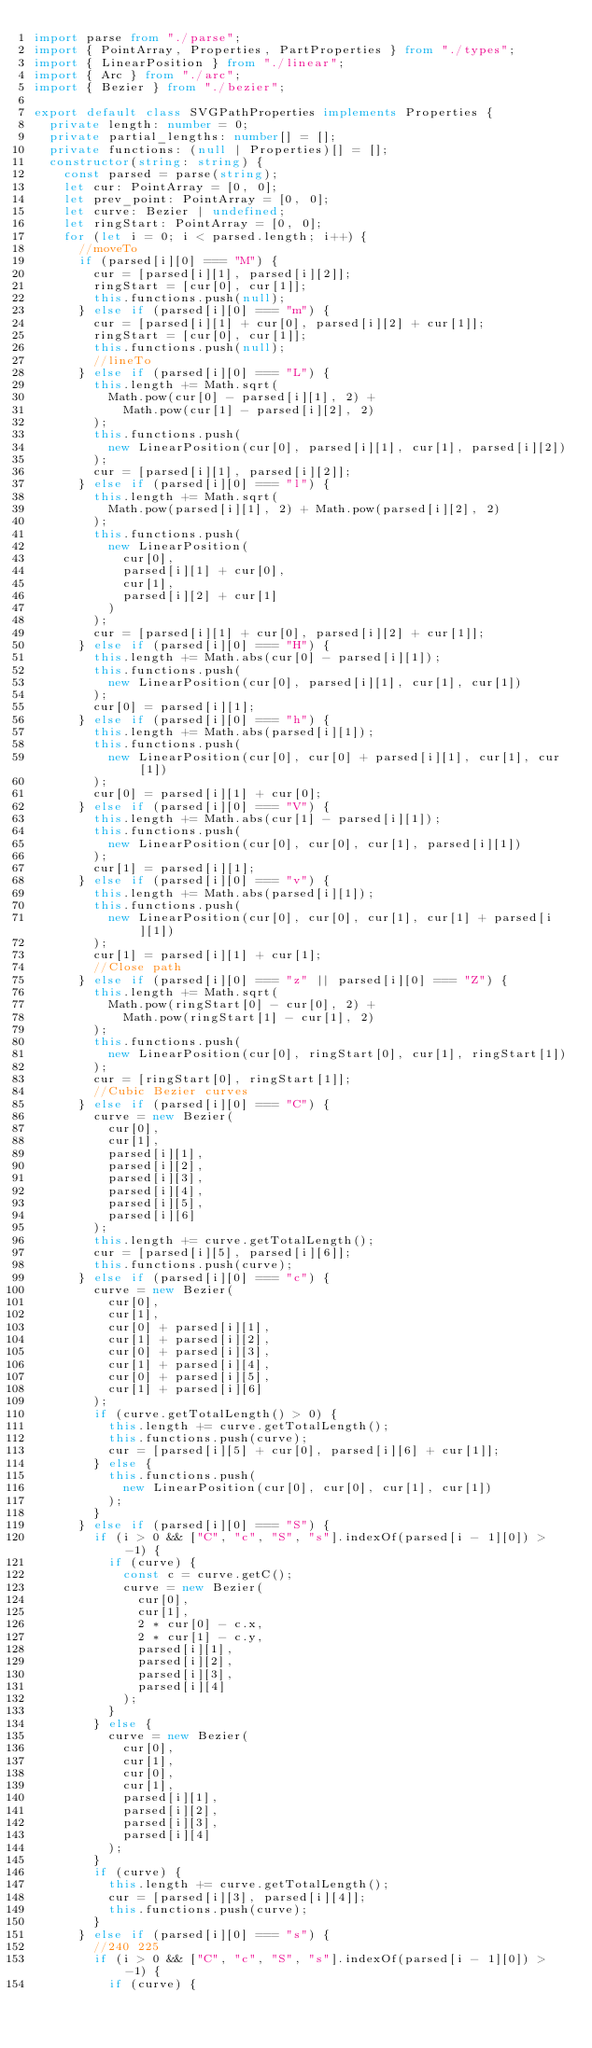<code> <loc_0><loc_0><loc_500><loc_500><_TypeScript_>import parse from "./parse";
import { PointArray, Properties, PartProperties } from "./types";
import { LinearPosition } from "./linear";
import { Arc } from "./arc";
import { Bezier } from "./bezier";

export default class SVGPathProperties implements Properties {
  private length: number = 0;
  private partial_lengths: number[] = [];
  private functions: (null | Properties)[] = [];
  constructor(string: string) {
    const parsed = parse(string);
    let cur: PointArray = [0, 0];
    let prev_point: PointArray = [0, 0];
    let curve: Bezier | undefined;
    let ringStart: PointArray = [0, 0];
    for (let i = 0; i < parsed.length; i++) {
      //moveTo
      if (parsed[i][0] === "M") {
        cur = [parsed[i][1], parsed[i][2]];
        ringStart = [cur[0], cur[1]];
        this.functions.push(null);
      } else if (parsed[i][0] === "m") {
        cur = [parsed[i][1] + cur[0], parsed[i][2] + cur[1]];
        ringStart = [cur[0], cur[1]];
        this.functions.push(null);
        //lineTo
      } else if (parsed[i][0] === "L") {
        this.length += Math.sqrt(
          Math.pow(cur[0] - parsed[i][1], 2) +
            Math.pow(cur[1] - parsed[i][2], 2)
        );
        this.functions.push(
          new LinearPosition(cur[0], parsed[i][1], cur[1], parsed[i][2])
        );
        cur = [parsed[i][1], parsed[i][2]];
      } else if (parsed[i][0] === "l") {
        this.length += Math.sqrt(
          Math.pow(parsed[i][1], 2) + Math.pow(parsed[i][2], 2)
        );
        this.functions.push(
          new LinearPosition(
            cur[0],
            parsed[i][1] + cur[0],
            cur[1],
            parsed[i][2] + cur[1]
          )
        );
        cur = [parsed[i][1] + cur[0], parsed[i][2] + cur[1]];
      } else if (parsed[i][0] === "H") {
        this.length += Math.abs(cur[0] - parsed[i][1]);
        this.functions.push(
          new LinearPosition(cur[0], parsed[i][1], cur[1], cur[1])
        );
        cur[0] = parsed[i][1];
      } else if (parsed[i][0] === "h") {
        this.length += Math.abs(parsed[i][1]);
        this.functions.push(
          new LinearPosition(cur[0], cur[0] + parsed[i][1], cur[1], cur[1])
        );
        cur[0] = parsed[i][1] + cur[0];
      } else if (parsed[i][0] === "V") {
        this.length += Math.abs(cur[1] - parsed[i][1]);
        this.functions.push(
          new LinearPosition(cur[0], cur[0], cur[1], parsed[i][1])
        );
        cur[1] = parsed[i][1];
      } else if (parsed[i][0] === "v") {
        this.length += Math.abs(parsed[i][1]);
        this.functions.push(
          new LinearPosition(cur[0], cur[0], cur[1], cur[1] + parsed[i][1])
        );
        cur[1] = parsed[i][1] + cur[1];
        //Close path
      } else if (parsed[i][0] === "z" || parsed[i][0] === "Z") {
        this.length += Math.sqrt(
          Math.pow(ringStart[0] - cur[0], 2) +
            Math.pow(ringStart[1] - cur[1], 2)
        );
        this.functions.push(
          new LinearPosition(cur[0], ringStart[0], cur[1], ringStart[1])
        );
        cur = [ringStart[0], ringStart[1]];
        //Cubic Bezier curves
      } else if (parsed[i][0] === "C") {
        curve = new Bezier(
          cur[0],
          cur[1],
          parsed[i][1],
          parsed[i][2],
          parsed[i][3],
          parsed[i][4],
          parsed[i][5],
          parsed[i][6]
        );
        this.length += curve.getTotalLength();
        cur = [parsed[i][5], parsed[i][6]];
        this.functions.push(curve);
      } else if (parsed[i][0] === "c") {
        curve = new Bezier(
          cur[0],
          cur[1],
          cur[0] + parsed[i][1],
          cur[1] + parsed[i][2],
          cur[0] + parsed[i][3],
          cur[1] + parsed[i][4],
          cur[0] + parsed[i][5],
          cur[1] + parsed[i][6]
        );
        if (curve.getTotalLength() > 0) {
          this.length += curve.getTotalLength();
          this.functions.push(curve);
          cur = [parsed[i][5] + cur[0], parsed[i][6] + cur[1]];
        } else {
          this.functions.push(
            new LinearPosition(cur[0], cur[0], cur[1], cur[1])
          );
        }
      } else if (parsed[i][0] === "S") {
        if (i > 0 && ["C", "c", "S", "s"].indexOf(parsed[i - 1][0]) > -1) {
          if (curve) {
            const c = curve.getC();
            curve = new Bezier(
              cur[0],
              cur[1],
              2 * cur[0] - c.x,
              2 * cur[1] - c.y,
              parsed[i][1],
              parsed[i][2],
              parsed[i][3],
              parsed[i][4]
            );
          }
        } else {
          curve = new Bezier(
            cur[0],
            cur[1],
            cur[0],
            cur[1],
            parsed[i][1],
            parsed[i][2],
            parsed[i][3],
            parsed[i][4]
          );
        }
        if (curve) {
          this.length += curve.getTotalLength();
          cur = [parsed[i][3], parsed[i][4]];
          this.functions.push(curve);
        }
      } else if (parsed[i][0] === "s") {
        //240 225
        if (i > 0 && ["C", "c", "S", "s"].indexOf(parsed[i - 1][0]) > -1) {
          if (curve) {</code> 